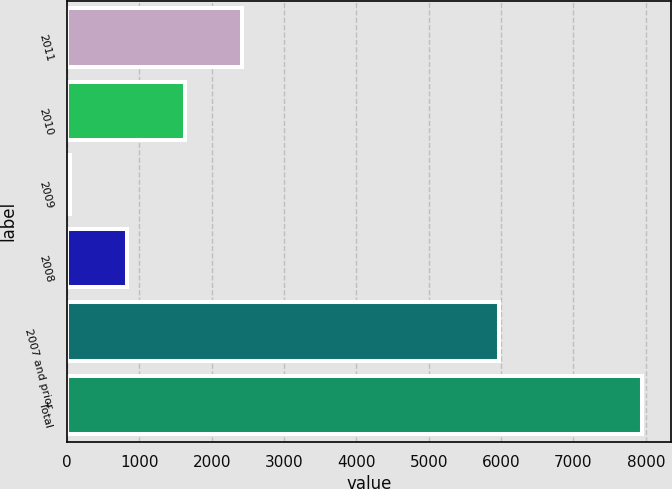Convert chart to OTSL. <chart><loc_0><loc_0><loc_500><loc_500><bar_chart><fcel>2011<fcel>2010<fcel>2009<fcel>2008<fcel>2007 and prior<fcel>Total<nl><fcel>2413.2<fcel>1622.8<fcel>42<fcel>832.4<fcel>5972<fcel>7946<nl></chart> 